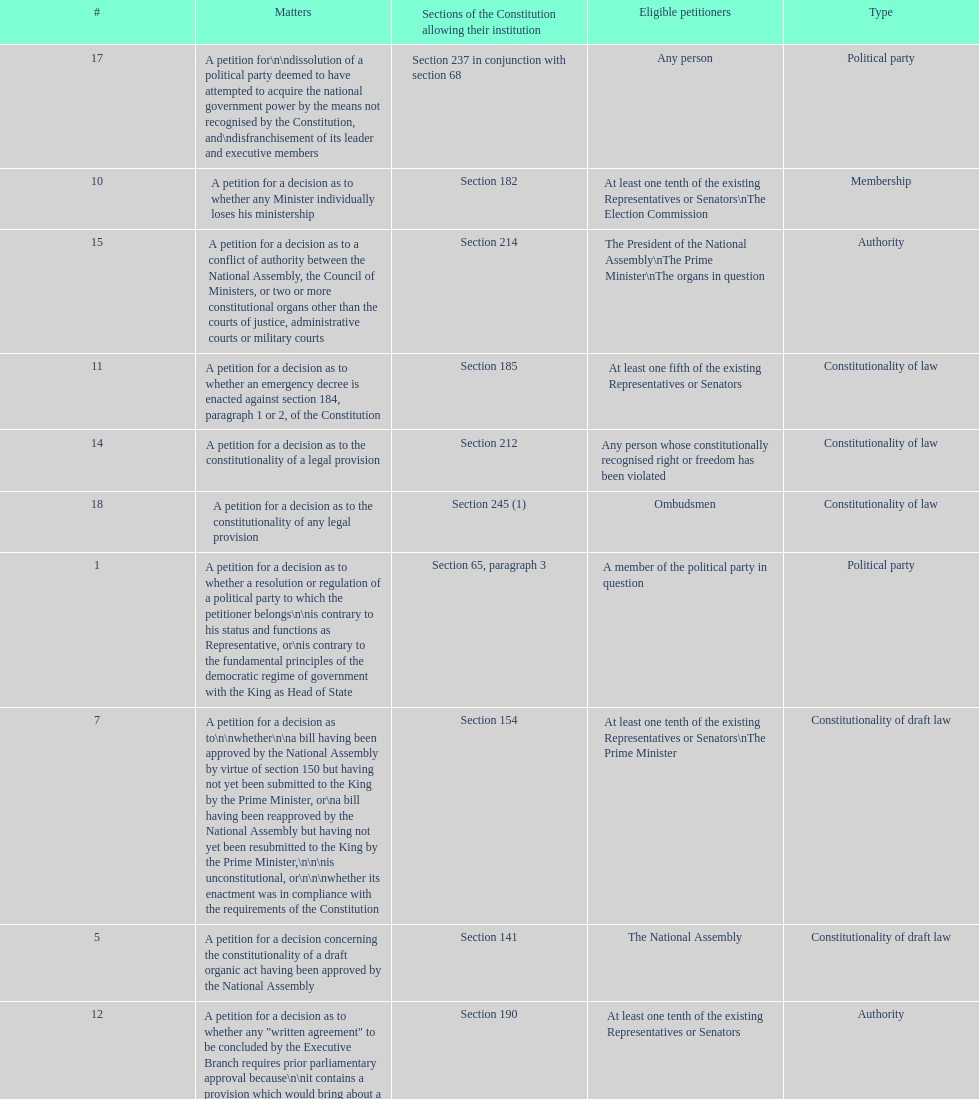Any person can petition matters 2 and 17. true or false? True. 